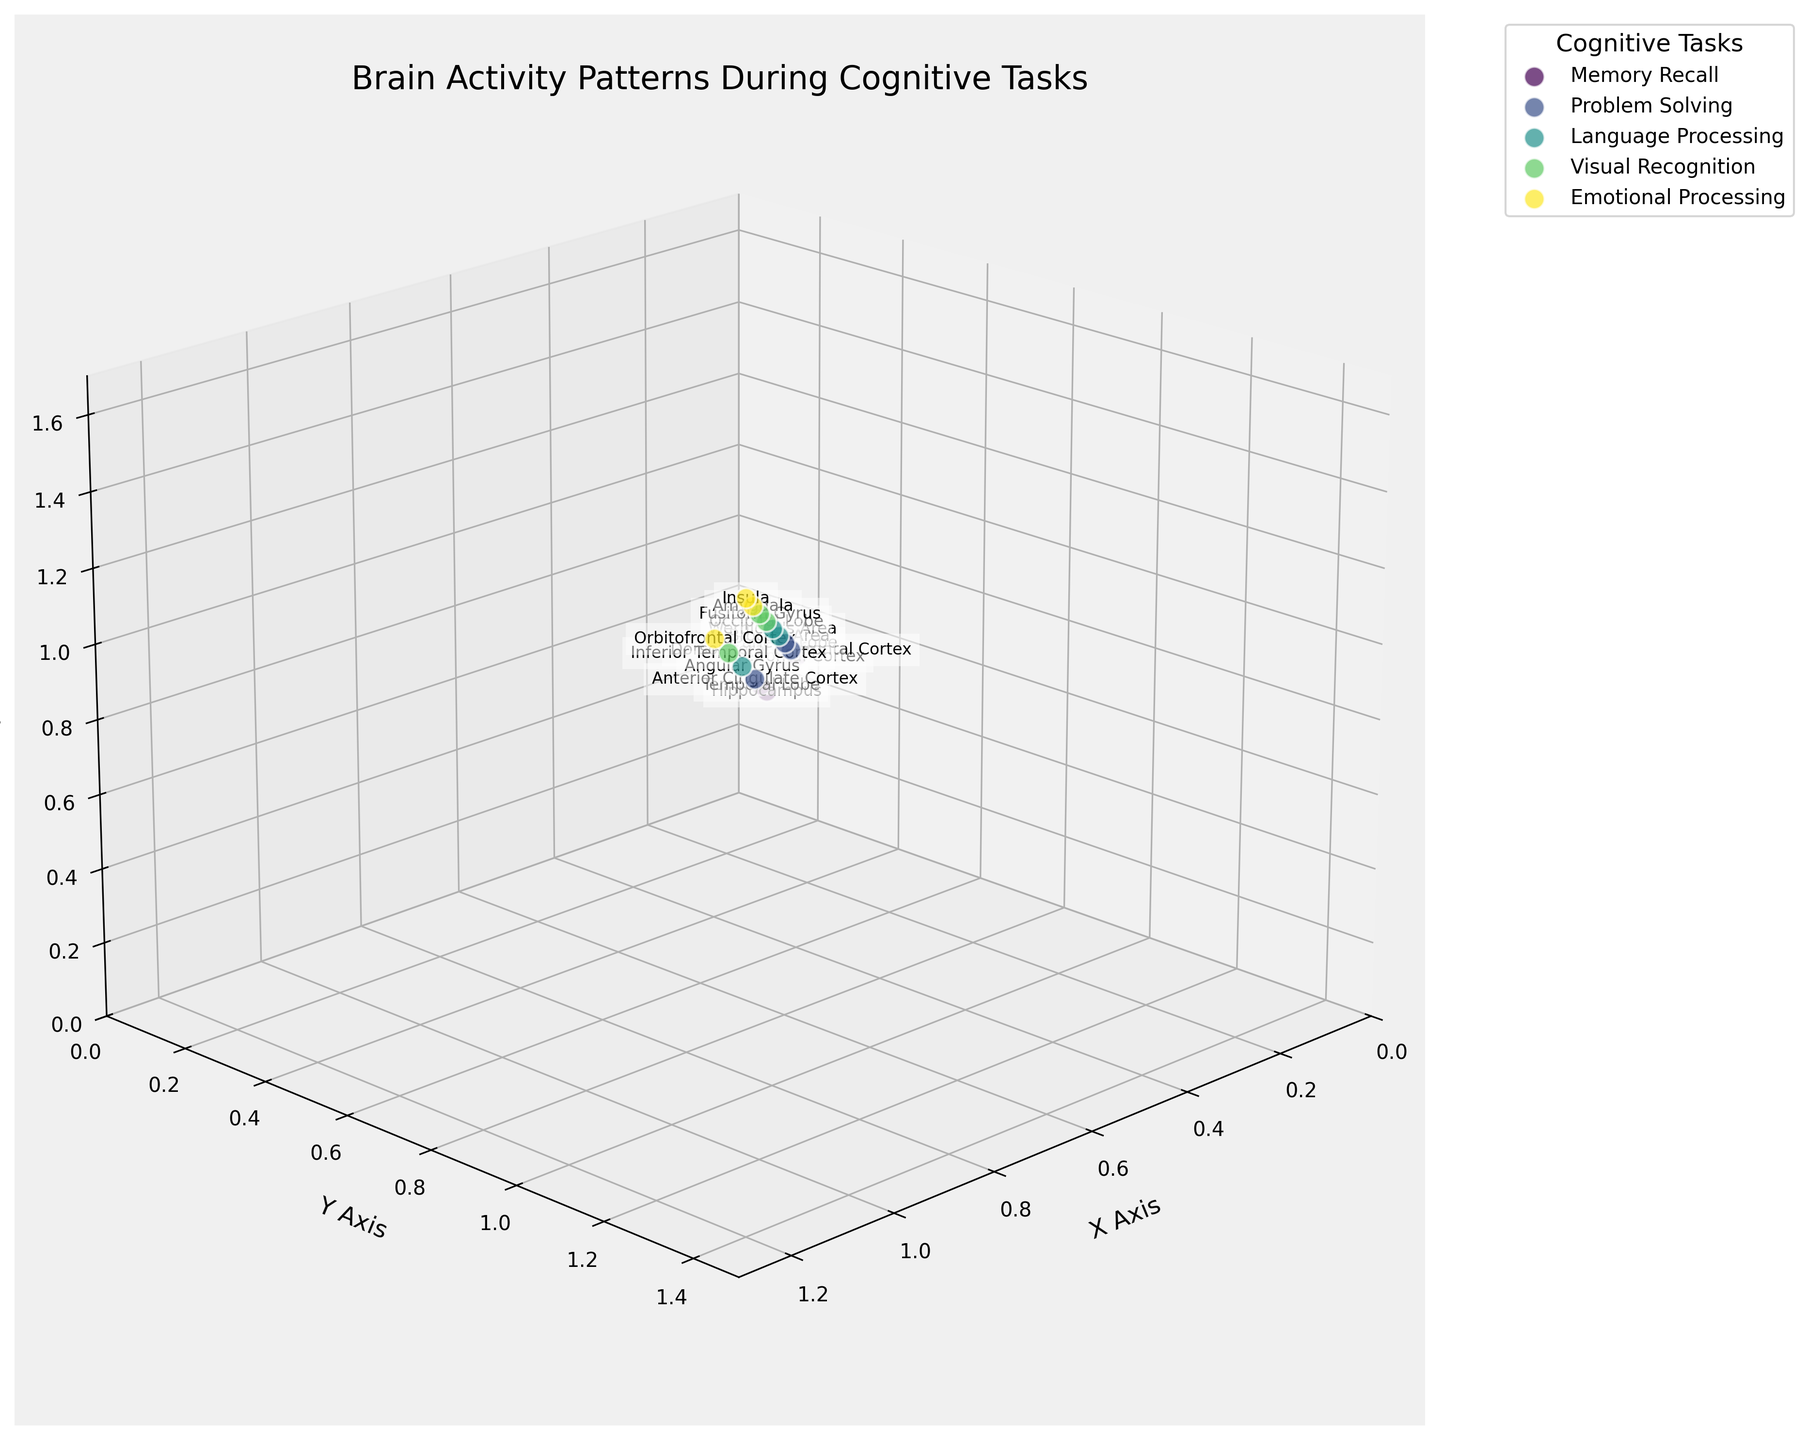What is the title of the figure? The title is located at the top of the figure. It generally provides a summary of what the plot illustrates. In this case, it mentions the context of brain activity and cognitive tasks.
Answer: Brain Activity Patterns During Cognitive Tasks How many cognitive tasks are represented in the plot? By examining the legend on the right side of the plot, we can count the number of unique tasks listed. Each task has a distinct color.
Answer: 5 Which brain region is associated with the highest z-value in the plot? To find this, we look for the data point with the highest z-coordinate and identify its corresponding brain region from the label next to it.
Answer: Orbitofrontal Cortex Which cognitive task has the most spread out data points in the z-axis? Observing the scatter of data points associated with each task, we note the range of z-values for each task. The task with the widest range in z-values will have the most spread out points.
Answer: Emotional Processing What is the average x-coordinate of data points for the Problem Solving task? First, locate the Problem Solving task data points. Add their x-coordinates and divide by the number of points to get the average. (0.5 + 0.6 + 0.4) / 3 = 1.5 / 3
Answer: 0.5 Which cognitive task's data points have the smallest range in y-coordinates? By comparing the range (difference between max and min values) of y-coordinates for each task's data points, we determine which has the smallest range.
Answer: Memory Recall How many data points represent the task related to Language Processing? Each task is color-coded and labeled in the legend. By counting the data points in the plot that match the color associated with Language Processing, we can determine the number.
Answer: 3 Which brain region corresponds to the point at the coordinates (0.9, 1.1, 1.3)? By inspecting the plot, locate the data point at these coordinates and see the label next to it to determine its region.
Answer: Occipital Lobe 